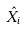Convert formula to latex. <formula><loc_0><loc_0><loc_500><loc_500>\hat { X } _ { i }</formula> 